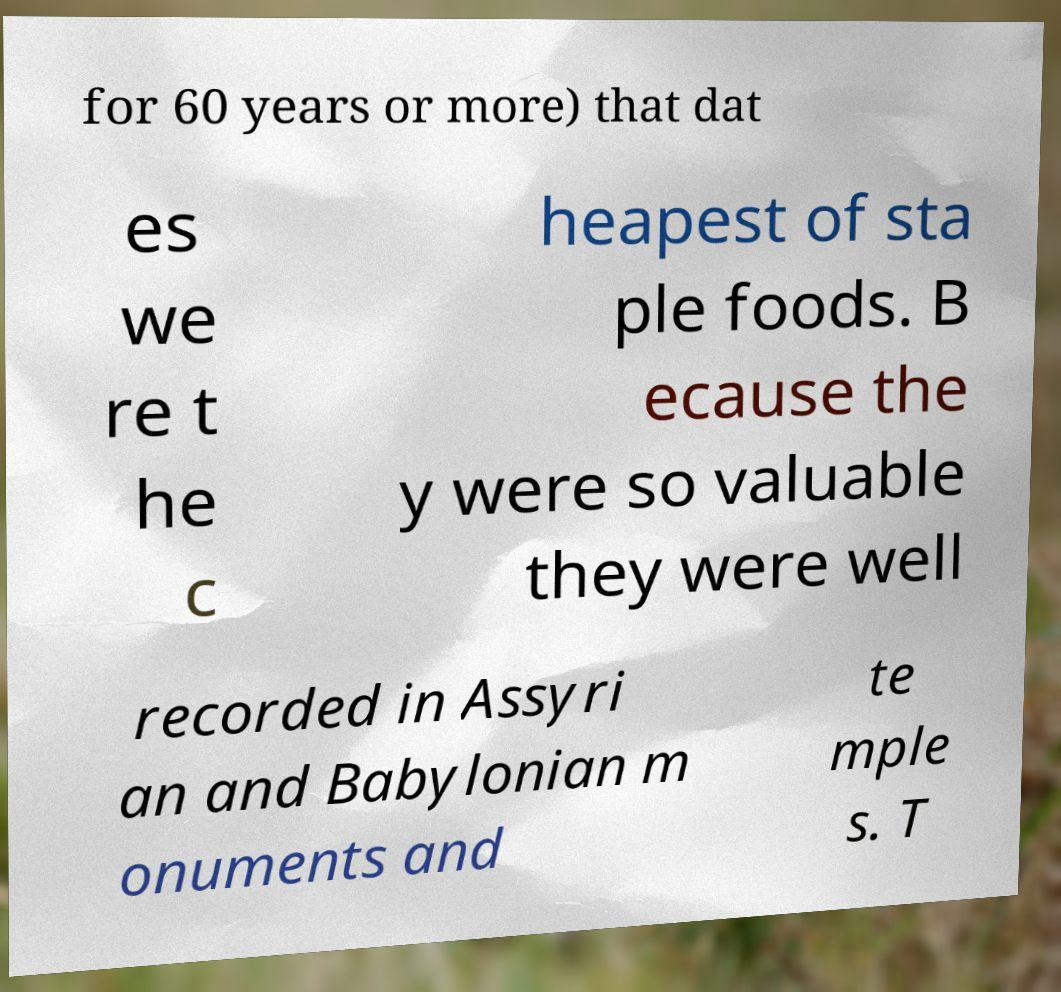Can you accurately transcribe the text from the provided image for me? for 60 years or more) that dat es we re t he c heapest of sta ple foods. B ecause the y were so valuable they were well recorded in Assyri an and Babylonian m onuments and te mple s. T 